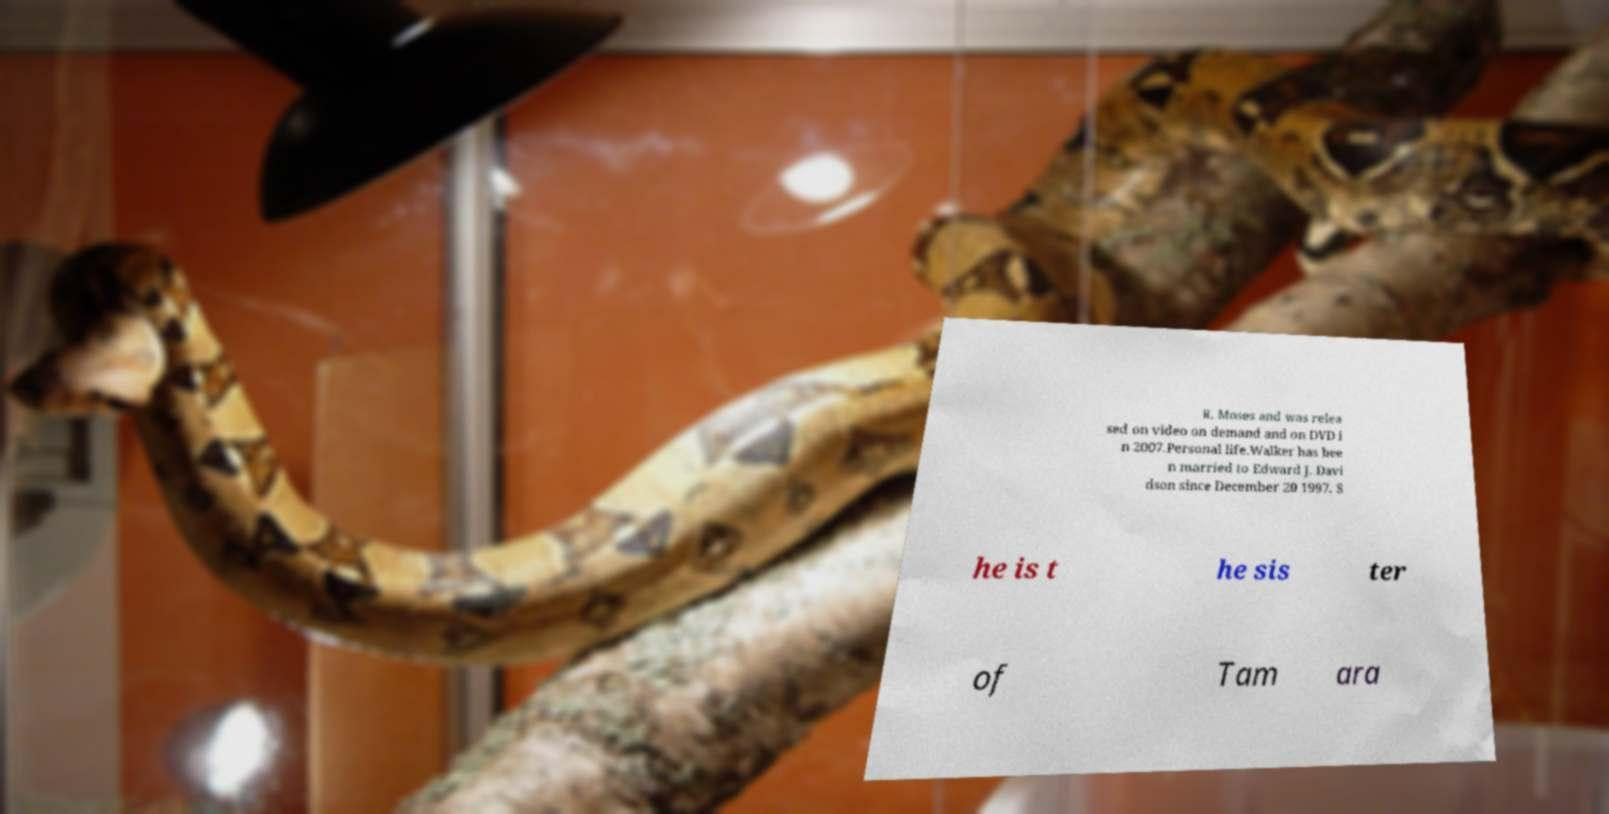Please read and relay the text visible in this image. What does it say? R. Moses and was relea sed on video on demand and on DVD i n 2007.Personal life.Walker has bee n married to Edward J. Davi dson since December 20 1997. S he is t he sis ter of Tam ara 